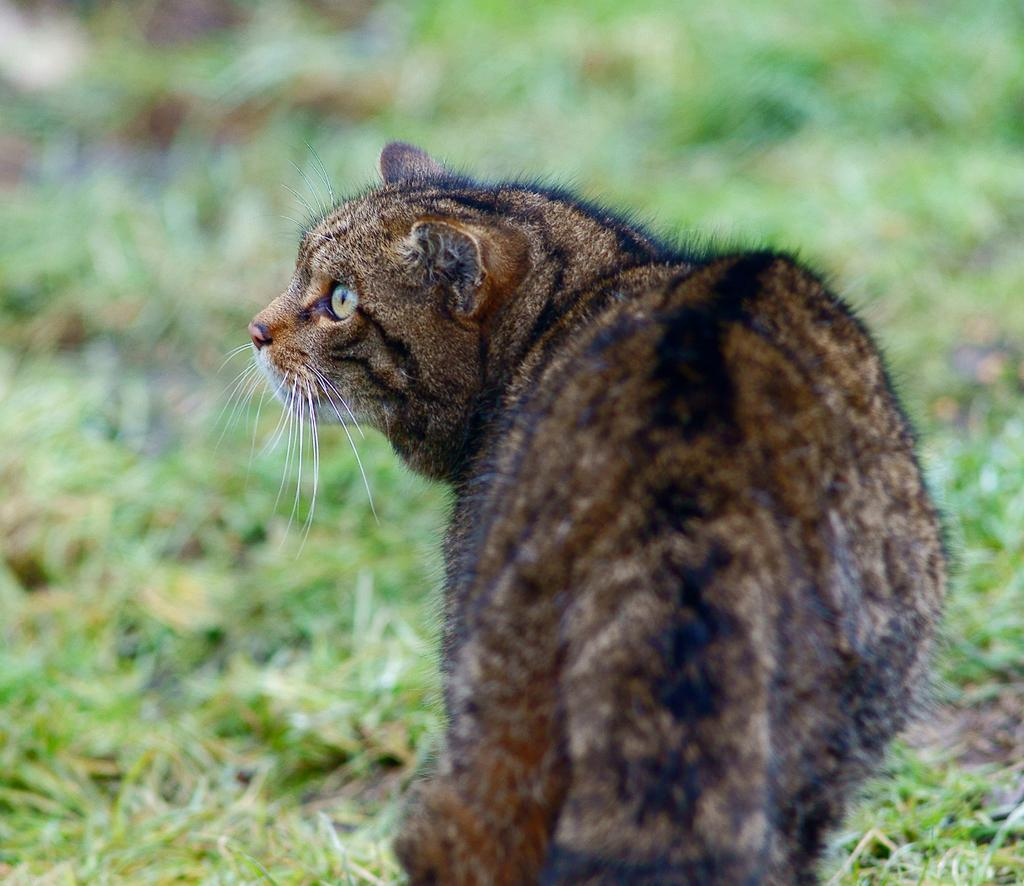What type of animal can be seen in the image? There is a cat in the image. What can be seen beneath the cat's feet? The ground is visible in the image, and there is grass on the ground. How would you describe the background of the image? The background of the image is blurred. What type of hose is being used to apply the substance to the stamp in the image? There is no hose, substance, or stamp present in the image. 